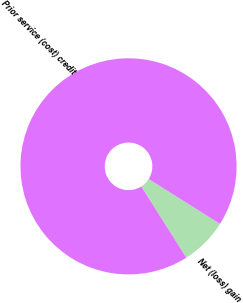<chart> <loc_0><loc_0><loc_500><loc_500><pie_chart><fcel>Net (loss) gain<fcel>Prior service (cost) credit<nl><fcel>7.08%<fcel>92.92%<nl></chart> 